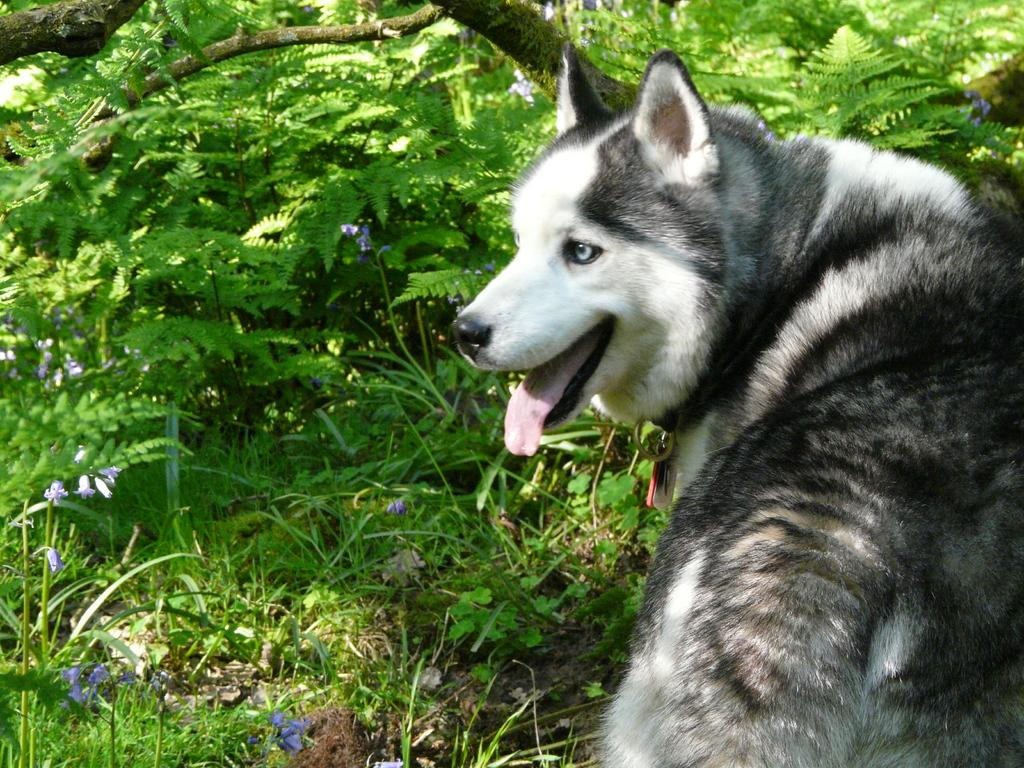What type of animal is in the image? There is a husky dog in the image. What is behind the dog in the image? There is a branch behind the dog. What type of vegetation is visible in the image? There is grass visible in the image. Are there any plants with flowers in the image? Yes, there are plants with flowers in the image. How many passengers are visible in the image? There are no passengers present in the image; it features a husky dog, a branch, grass, and plants with flowers. 